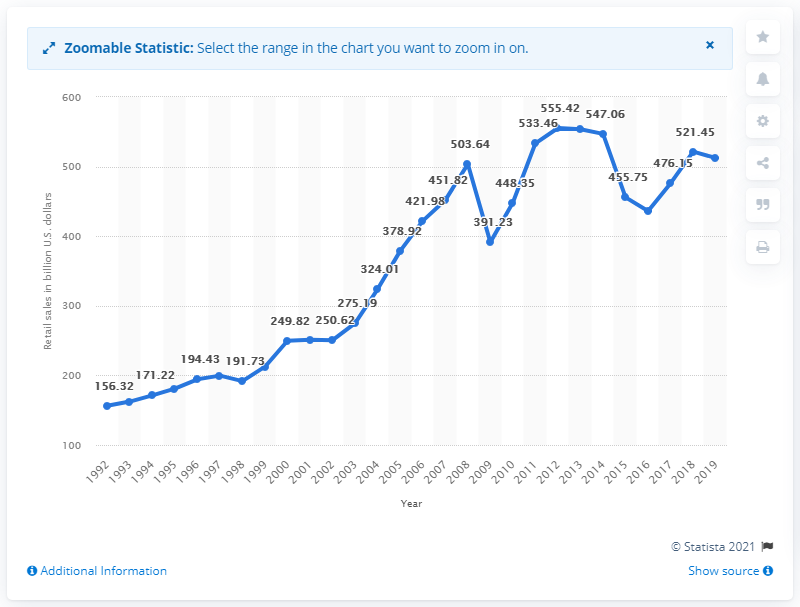Draw attention to some important aspects in this diagram. In the United States in 2019, the sales at gasoline stations were approximately $512.38 million. 